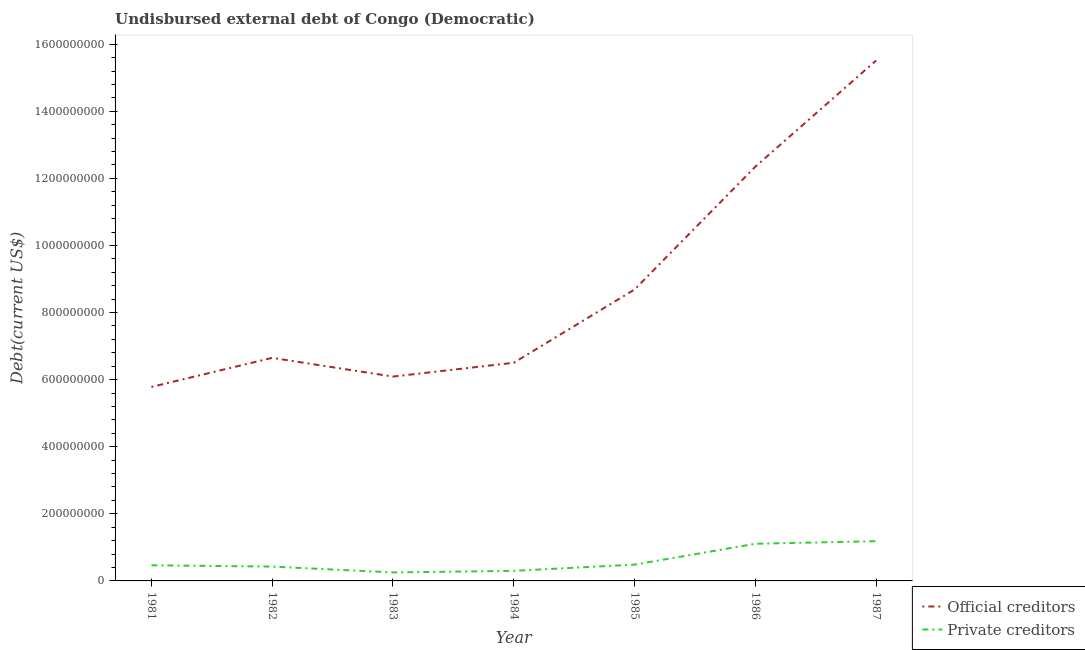Does the line corresponding to undisbursed external debt of private creditors intersect with the line corresponding to undisbursed external debt of official creditors?
Give a very brief answer. No. Is the number of lines equal to the number of legend labels?
Your answer should be compact. Yes. What is the undisbursed external debt of official creditors in 1981?
Offer a very short reply. 5.78e+08. Across all years, what is the maximum undisbursed external debt of official creditors?
Your answer should be very brief. 1.55e+09. Across all years, what is the minimum undisbursed external debt of official creditors?
Your answer should be very brief. 5.78e+08. In which year was the undisbursed external debt of official creditors minimum?
Offer a terse response. 1981. What is the total undisbursed external debt of private creditors in the graph?
Give a very brief answer. 4.23e+08. What is the difference between the undisbursed external debt of official creditors in 1984 and that in 1985?
Give a very brief answer. -2.18e+08. What is the difference between the undisbursed external debt of official creditors in 1982 and the undisbursed external debt of private creditors in 1985?
Give a very brief answer. 6.16e+08. What is the average undisbursed external debt of official creditors per year?
Your answer should be compact. 8.80e+08. In the year 1983, what is the difference between the undisbursed external debt of private creditors and undisbursed external debt of official creditors?
Offer a terse response. -5.84e+08. In how many years, is the undisbursed external debt of private creditors greater than 840000000 US$?
Give a very brief answer. 0. What is the ratio of the undisbursed external debt of official creditors in 1981 to that in 1983?
Offer a very short reply. 0.95. Is the undisbursed external debt of private creditors in 1983 less than that in 1985?
Your answer should be compact. Yes. Is the difference between the undisbursed external debt of official creditors in 1983 and 1985 greater than the difference between the undisbursed external debt of private creditors in 1983 and 1985?
Make the answer very short. No. What is the difference between the highest and the second highest undisbursed external debt of official creditors?
Your answer should be compact. 3.17e+08. What is the difference between the highest and the lowest undisbursed external debt of private creditors?
Offer a terse response. 9.31e+07. In how many years, is the undisbursed external debt of private creditors greater than the average undisbursed external debt of private creditors taken over all years?
Keep it short and to the point. 2. Is the sum of the undisbursed external debt of official creditors in 1981 and 1985 greater than the maximum undisbursed external debt of private creditors across all years?
Your answer should be very brief. Yes. Does the undisbursed external debt of official creditors monotonically increase over the years?
Make the answer very short. No. Is the undisbursed external debt of private creditors strictly greater than the undisbursed external debt of official creditors over the years?
Your answer should be very brief. No. Is the undisbursed external debt of official creditors strictly less than the undisbursed external debt of private creditors over the years?
Your response must be concise. No. How many lines are there?
Make the answer very short. 2. How many years are there in the graph?
Offer a terse response. 7. Does the graph contain any zero values?
Your answer should be very brief. No. Where does the legend appear in the graph?
Keep it short and to the point. Bottom right. How many legend labels are there?
Keep it short and to the point. 2. How are the legend labels stacked?
Give a very brief answer. Vertical. What is the title of the graph?
Offer a very short reply. Undisbursed external debt of Congo (Democratic). What is the label or title of the Y-axis?
Provide a short and direct response. Debt(current US$). What is the Debt(current US$) of Official creditors in 1981?
Your answer should be very brief. 5.78e+08. What is the Debt(current US$) in Private creditors in 1981?
Keep it short and to the point. 4.66e+07. What is the Debt(current US$) in Official creditors in 1982?
Provide a succinct answer. 6.65e+08. What is the Debt(current US$) in Private creditors in 1982?
Ensure brevity in your answer.  4.27e+07. What is the Debt(current US$) of Official creditors in 1983?
Your answer should be compact. 6.09e+08. What is the Debt(current US$) in Private creditors in 1983?
Ensure brevity in your answer.  2.53e+07. What is the Debt(current US$) in Official creditors in 1984?
Make the answer very short. 6.50e+08. What is the Debt(current US$) in Private creditors in 1984?
Make the answer very short. 3.00e+07. What is the Debt(current US$) in Official creditors in 1985?
Make the answer very short. 8.69e+08. What is the Debt(current US$) of Private creditors in 1985?
Your answer should be very brief. 4.86e+07. What is the Debt(current US$) in Official creditors in 1986?
Make the answer very short. 1.23e+09. What is the Debt(current US$) of Private creditors in 1986?
Keep it short and to the point. 1.11e+08. What is the Debt(current US$) of Official creditors in 1987?
Your answer should be compact. 1.55e+09. What is the Debt(current US$) of Private creditors in 1987?
Make the answer very short. 1.18e+08. Across all years, what is the maximum Debt(current US$) in Official creditors?
Provide a succinct answer. 1.55e+09. Across all years, what is the maximum Debt(current US$) of Private creditors?
Provide a short and direct response. 1.18e+08. Across all years, what is the minimum Debt(current US$) in Official creditors?
Offer a very short reply. 5.78e+08. Across all years, what is the minimum Debt(current US$) in Private creditors?
Offer a terse response. 2.53e+07. What is the total Debt(current US$) of Official creditors in the graph?
Give a very brief answer. 6.16e+09. What is the total Debt(current US$) of Private creditors in the graph?
Keep it short and to the point. 4.23e+08. What is the difference between the Debt(current US$) in Official creditors in 1981 and that in 1982?
Keep it short and to the point. -8.67e+07. What is the difference between the Debt(current US$) of Private creditors in 1981 and that in 1982?
Offer a terse response. 3.88e+06. What is the difference between the Debt(current US$) of Official creditors in 1981 and that in 1983?
Make the answer very short. -3.09e+07. What is the difference between the Debt(current US$) of Private creditors in 1981 and that in 1983?
Your response must be concise. 2.13e+07. What is the difference between the Debt(current US$) of Official creditors in 1981 and that in 1984?
Provide a short and direct response. -7.21e+07. What is the difference between the Debt(current US$) of Private creditors in 1981 and that in 1984?
Keep it short and to the point. 1.66e+07. What is the difference between the Debt(current US$) of Official creditors in 1981 and that in 1985?
Ensure brevity in your answer.  -2.90e+08. What is the difference between the Debt(current US$) in Private creditors in 1981 and that in 1985?
Give a very brief answer. -2.02e+06. What is the difference between the Debt(current US$) of Official creditors in 1981 and that in 1986?
Provide a short and direct response. -6.57e+08. What is the difference between the Debt(current US$) of Private creditors in 1981 and that in 1986?
Keep it short and to the point. -6.42e+07. What is the difference between the Debt(current US$) of Official creditors in 1981 and that in 1987?
Your response must be concise. -9.73e+08. What is the difference between the Debt(current US$) in Private creditors in 1981 and that in 1987?
Provide a short and direct response. -7.19e+07. What is the difference between the Debt(current US$) in Official creditors in 1982 and that in 1983?
Your answer should be very brief. 5.58e+07. What is the difference between the Debt(current US$) of Private creditors in 1982 and that in 1983?
Offer a terse response. 1.74e+07. What is the difference between the Debt(current US$) of Official creditors in 1982 and that in 1984?
Provide a short and direct response. 1.46e+07. What is the difference between the Debt(current US$) in Private creditors in 1982 and that in 1984?
Your response must be concise. 1.27e+07. What is the difference between the Debt(current US$) in Official creditors in 1982 and that in 1985?
Provide a short and direct response. -2.04e+08. What is the difference between the Debt(current US$) of Private creditors in 1982 and that in 1985?
Make the answer very short. -5.90e+06. What is the difference between the Debt(current US$) of Official creditors in 1982 and that in 1986?
Keep it short and to the point. -5.70e+08. What is the difference between the Debt(current US$) in Private creditors in 1982 and that in 1986?
Your response must be concise. -6.81e+07. What is the difference between the Debt(current US$) in Official creditors in 1982 and that in 1987?
Ensure brevity in your answer.  -8.87e+08. What is the difference between the Debt(current US$) of Private creditors in 1982 and that in 1987?
Your response must be concise. -7.58e+07. What is the difference between the Debt(current US$) in Official creditors in 1983 and that in 1984?
Ensure brevity in your answer.  -4.12e+07. What is the difference between the Debt(current US$) of Private creditors in 1983 and that in 1984?
Provide a succinct answer. -4.67e+06. What is the difference between the Debt(current US$) in Official creditors in 1983 and that in 1985?
Keep it short and to the point. -2.60e+08. What is the difference between the Debt(current US$) of Private creditors in 1983 and that in 1985?
Keep it short and to the point. -2.33e+07. What is the difference between the Debt(current US$) in Official creditors in 1983 and that in 1986?
Offer a terse response. -6.26e+08. What is the difference between the Debt(current US$) of Private creditors in 1983 and that in 1986?
Your answer should be compact. -8.54e+07. What is the difference between the Debt(current US$) of Official creditors in 1983 and that in 1987?
Your response must be concise. -9.42e+08. What is the difference between the Debt(current US$) of Private creditors in 1983 and that in 1987?
Offer a very short reply. -9.31e+07. What is the difference between the Debt(current US$) of Official creditors in 1984 and that in 1985?
Keep it short and to the point. -2.18e+08. What is the difference between the Debt(current US$) in Private creditors in 1984 and that in 1985?
Keep it short and to the point. -1.86e+07. What is the difference between the Debt(current US$) in Official creditors in 1984 and that in 1986?
Your answer should be compact. -5.85e+08. What is the difference between the Debt(current US$) of Private creditors in 1984 and that in 1986?
Keep it short and to the point. -8.08e+07. What is the difference between the Debt(current US$) of Official creditors in 1984 and that in 1987?
Keep it short and to the point. -9.01e+08. What is the difference between the Debt(current US$) of Private creditors in 1984 and that in 1987?
Your answer should be very brief. -8.85e+07. What is the difference between the Debt(current US$) of Official creditors in 1985 and that in 1986?
Ensure brevity in your answer.  -3.66e+08. What is the difference between the Debt(current US$) in Private creditors in 1985 and that in 1986?
Make the answer very short. -6.22e+07. What is the difference between the Debt(current US$) in Official creditors in 1985 and that in 1987?
Offer a terse response. -6.83e+08. What is the difference between the Debt(current US$) in Private creditors in 1985 and that in 1987?
Provide a short and direct response. -6.99e+07. What is the difference between the Debt(current US$) in Official creditors in 1986 and that in 1987?
Make the answer very short. -3.17e+08. What is the difference between the Debt(current US$) of Private creditors in 1986 and that in 1987?
Keep it short and to the point. -7.70e+06. What is the difference between the Debt(current US$) in Official creditors in 1981 and the Debt(current US$) in Private creditors in 1982?
Keep it short and to the point. 5.36e+08. What is the difference between the Debt(current US$) of Official creditors in 1981 and the Debt(current US$) of Private creditors in 1983?
Give a very brief answer. 5.53e+08. What is the difference between the Debt(current US$) in Official creditors in 1981 and the Debt(current US$) in Private creditors in 1984?
Offer a very short reply. 5.48e+08. What is the difference between the Debt(current US$) of Official creditors in 1981 and the Debt(current US$) of Private creditors in 1985?
Provide a succinct answer. 5.30e+08. What is the difference between the Debt(current US$) of Official creditors in 1981 and the Debt(current US$) of Private creditors in 1986?
Your response must be concise. 4.67e+08. What is the difference between the Debt(current US$) of Official creditors in 1981 and the Debt(current US$) of Private creditors in 1987?
Offer a terse response. 4.60e+08. What is the difference between the Debt(current US$) in Official creditors in 1982 and the Debt(current US$) in Private creditors in 1983?
Your response must be concise. 6.40e+08. What is the difference between the Debt(current US$) of Official creditors in 1982 and the Debt(current US$) of Private creditors in 1984?
Your response must be concise. 6.35e+08. What is the difference between the Debt(current US$) in Official creditors in 1982 and the Debt(current US$) in Private creditors in 1985?
Offer a very short reply. 6.16e+08. What is the difference between the Debt(current US$) of Official creditors in 1982 and the Debt(current US$) of Private creditors in 1986?
Your response must be concise. 5.54e+08. What is the difference between the Debt(current US$) in Official creditors in 1982 and the Debt(current US$) in Private creditors in 1987?
Offer a terse response. 5.47e+08. What is the difference between the Debt(current US$) of Official creditors in 1983 and the Debt(current US$) of Private creditors in 1984?
Your response must be concise. 5.79e+08. What is the difference between the Debt(current US$) in Official creditors in 1983 and the Debt(current US$) in Private creditors in 1985?
Your answer should be very brief. 5.61e+08. What is the difference between the Debt(current US$) of Official creditors in 1983 and the Debt(current US$) of Private creditors in 1986?
Ensure brevity in your answer.  4.98e+08. What is the difference between the Debt(current US$) in Official creditors in 1983 and the Debt(current US$) in Private creditors in 1987?
Make the answer very short. 4.91e+08. What is the difference between the Debt(current US$) of Official creditors in 1984 and the Debt(current US$) of Private creditors in 1985?
Offer a terse response. 6.02e+08. What is the difference between the Debt(current US$) in Official creditors in 1984 and the Debt(current US$) in Private creditors in 1986?
Your answer should be compact. 5.40e+08. What is the difference between the Debt(current US$) in Official creditors in 1984 and the Debt(current US$) in Private creditors in 1987?
Provide a succinct answer. 5.32e+08. What is the difference between the Debt(current US$) of Official creditors in 1985 and the Debt(current US$) of Private creditors in 1986?
Your response must be concise. 7.58e+08. What is the difference between the Debt(current US$) of Official creditors in 1985 and the Debt(current US$) of Private creditors in 1987?
Your answer should be compact. 7.50e+08. What is the difference between the Debt(current US$) in Official creditors in 1986 and the Debt(current US$) in Private creditors in 1987?
Offer a very short reply. 1.12e+09. What is the average Debt(current US$) of Official creditors per year?
Make the answer very short. 8.80e+08. What is the average Debt(current US$) in Private creditors per year?
Provide a short and direct response. 6.04e+07. In the year 1981, what is the difference between the Debt(current US$) in Official creditors and Debt(current US$) in Private creditors?
Offer a terse response. 5.32e+08. In the year 1982, what is the difference between the Debt(current US$) in Official creditors and Debt(current US$) in Private creditors?
Provide a short and direct response. 6.22e+08. In the year 1983, what is the difference between the Debt(current US$) in Official creditors and Debt(current US$) in Private creditors?
Your answer should be compact. 5.84e+08. In the year 1984, what is the difference between the Debt(current US$) of Official creditors and Debt(current US$) of Private creditors?
Ensure brevity in your answer.  6.20e+08. In the year 1985, what is the difference between the Debt(current US$) in Official creditors and Debt(current US$) in Private creditors?
Provide a succinct answer. 8.20e+08. In the year 1986, what is the difference between the Debt(current US$) of Official creditors and Debt(current US$) of Private creditors?
Offer a very short reply. 1.12e+09. In the year 1987, what is the difference between the Debt(current US$) in Official creditors and Debt(current US$) in Private creditors?
Provide a short and direct response. 1.43e+09. What is the ratio of the Debt(current US$) in Official creditors in 1981 to that in 1982?
Offer a terse response. 0.87. What is the ratio of the Debt(current US$) of Private creditors in 1981 to that in 1982?
Offer a terse response. 1.09. What is the ratio of the Debt(current US$) of Official creditors in 1981 to that in 1983?
Make the answer very short. 0.95. What is the ratio of the Debt(current US$) of Private creditors in 1981 to that in 1983?
Provide a succinct answer. 1.84. What is the ratio of the Debt(current US$) in Official creditors in 1981 to that in 1984?
Make the answer very short. 0.89. What is the ratio of the Debt(current US$) in Private creditors in 1981 to that in 1984?
Provide a succinct answer. 1.55. What is the ratio of the Debt(current US$) in Official creditors in 1981 to that in 1985?
Give a very brief answer. 0.67. What is the ratio of the Debt(current US$) in Private creditors in 1981 to that in 1985?
Your response must be concise. 0.96. What is the ratio of the Debt(current US$) in Official creditors in 1981 to that in 1986?
Keep it short and to the point. 0.47. What is the ratio of the Debt(current US$) of Private creditors in 1981 to that in 1986?
Your answer should be compact. 0.42. What is the ratio of the Debt(current US$) of Official creditors in 1981 to that in 1987?
Provide a short and direct response. 0.37. What is the ratio of the Debt(current US$) of Private creditors in 1981 to that in 1987?
Make the answer very short. 0.39. What is the ratio of the Debt(current US$) in Official creditors in 1982 to that in 1983?
Make the answer very short. 1.09. What is the ratio of the Debt(current US$) in Private creditors in 1982 to that in 1983?
Make the answer very short. 1.69. What is the ratio of the Debt(current US$) of Official creditors in 1982 to that in 1984?
Make the answer very short. 1.02. What is the ratio of the Debt(current US$) of Private creditors in 1982 to that in 1984?
Give a very brief answer. 1.42. What is the ratio of the Debt(current US$) of Official creditors in 1982 to that in 1985?
Your response must be concise. 0.77. What is the ratio of the Debt(current US$) in Private creditors in 1982 to that in 1985?
Offer a very short reply. 0.88. What is the ratio of the Debt(current US$) in Official creditors in 1982 to that in 1986?
Ensure brevity in your answer.  0.54. What is the ratio of the Debt(current US$) of Private creditors in 1982 to that in 1986?
Offer a very short reply. 0.39. What is the ratio of the Debt(current US$) of Official creditors in 1982 to that in 1987?
Your answer should be compact. 0.43. What is the ratio of the Debt(current US$) in Private creditors in 1982 to that in 1987?
Offer a terse response. 0.36. What is the ratio of the Debt(current US$) in Official creditors in 1983 to that in 1984?
Provide a short and direct response. 0.94. What is the ratio of the Debt(current US$) of Private creditors in 1983 to that in 1984?
Your response must be concise. 0.84. What is the ratio of the Debt(current US$) in Official creditors in 1983 to that in 1985?
Offer a very short reply. 0.7. What is the ratio of the Debt(current US$) in Private creditors in 1983 to that in 1985?
Your answer should be very brief. 0.52. What is the ratio of the Debt(current US$) in Official creditors in 1983 to that in 1986?
Your response must be concise. 0.49. What is the ratio of the Debt(current US$) of Private creditors in 1983 to that in 1986?
Provide a succinct answer. 0.23. What is the ratio of the Debt(current US$) in Official creditors in 1983 to that in 1987?
Provide a succinct answer. 0.39. What is the ratio of the Debt(current US$) of Private creditors in 1983 to that in 1987?
Your response must be concise. 0.21. What is the ratio of the Debt(current US$) in Official creditors in 1984 to that in 1985?
Your answer should be very brief. 0.75. What is the ratio of the Debt(current US$) in Private creditors in 1984 to that in 1985?
Provide a succinct answer. 0.62. What is the ratio of the Debt(current US$) in Official creditors in 1984 to that in 1986?
Your response must be concise. 0.53. What is the ratio of the Debt(current US$) of Private creditors in 1984 to that in 1986?
Offer a terse response. 0.27. What is the ratio of the Debt(current US$) in Official creditors in 1984 to that in 1987?
Offer a terse response. 0.42. What is the ratio of the Debt(current US$) of Private creditors in 1984 to that in 1987?
Provide a succinct answer. 0.25. What is the ratio of the Debt(current US$) of Official creditors in 1985 to that in 1986?
Give a very brief answer. 0.7. What is the ratio of the Debt(current US$) in Private creditors in 1985 to that in 1986?
Provide a short and direct response. 0.44. What is the ratio of the Debt(current US$) in Official creditors in 1985 to that in 1987?
Your answer should be compact. 0.56. What is the ratio of the Debt(current US$) of Private creditors in 1985 to that in 1987?
Your answer should be compact. 0.41. What is the ratio of the Debt(current US$) of Official creditors in 1986 to that in 1987?
Your answer should be very brief. 0.8. What is the ratio of the Debt(current US$) in Private creditors in 1986 to that in 1987?
Ensure brevity in your answer.  0.94. What is the difference between the highest and the second highest Debt(current US$) of Official creditors?
Give a very brief answer. 3.17e+08. What is the difference between the highest and the second highest Debt(current US$) in Private creditors?
Provide a succinct answer. 7.70e+06. What is the difference between the highest and the lowest Debt(current US$) of Official creditors?
Your answer should be very brief. 9.73e+08. What is the difference between the highest and the lowest Debt(current US$) of Private creditors?
Provide a succinct answer. 9.31e+07. 